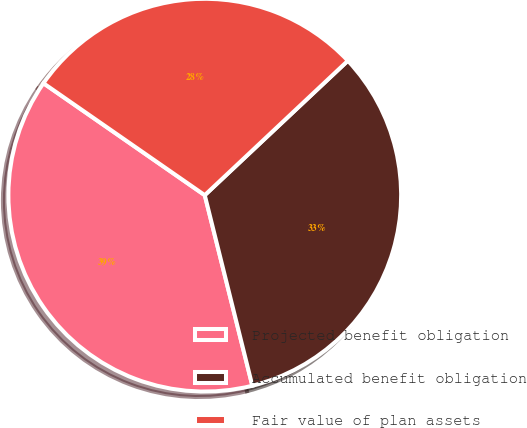<chart> <loc_0><loc_0><loc_500><loc_500><pie_chart><fcel>Projected benefit obligation<fcel>Accumulated benefit obligation<fcel>Fair value of plan assets<nl><fcel>38.55%<fcel>33.11%<fcel>28.34%<nl></chart> 